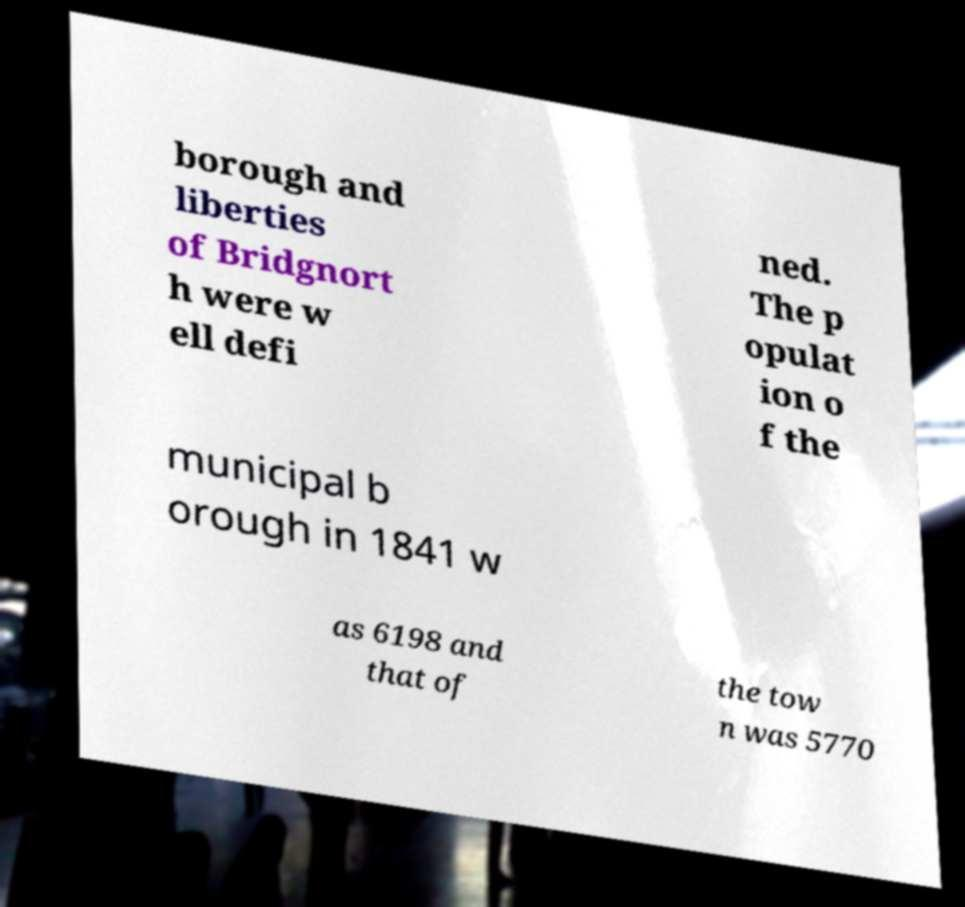Can you accurately transcribe the text from the provided image for me? borough and liberties of Bridgnort h were w ell defi ned. The p opulat ion o f the municipal b orough in 1841 w as 6198 and that of the tow n was 5770 